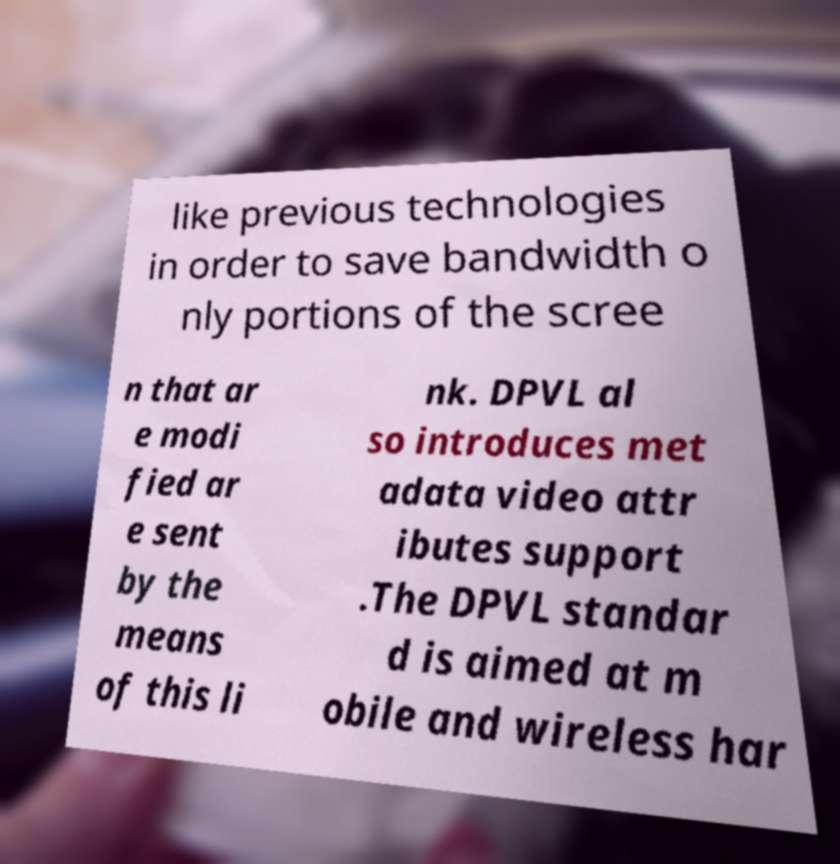Please read and relay the text visible in this image. What does it say? like previous technologies in order to save bandwidth o nly portions of the scree n that ar e modi fied ar e sent by the means of this li nk. DPVL al so introduces met adata video attr ibutes support .The DPVL standar d is aimed at m obile and wireless har 